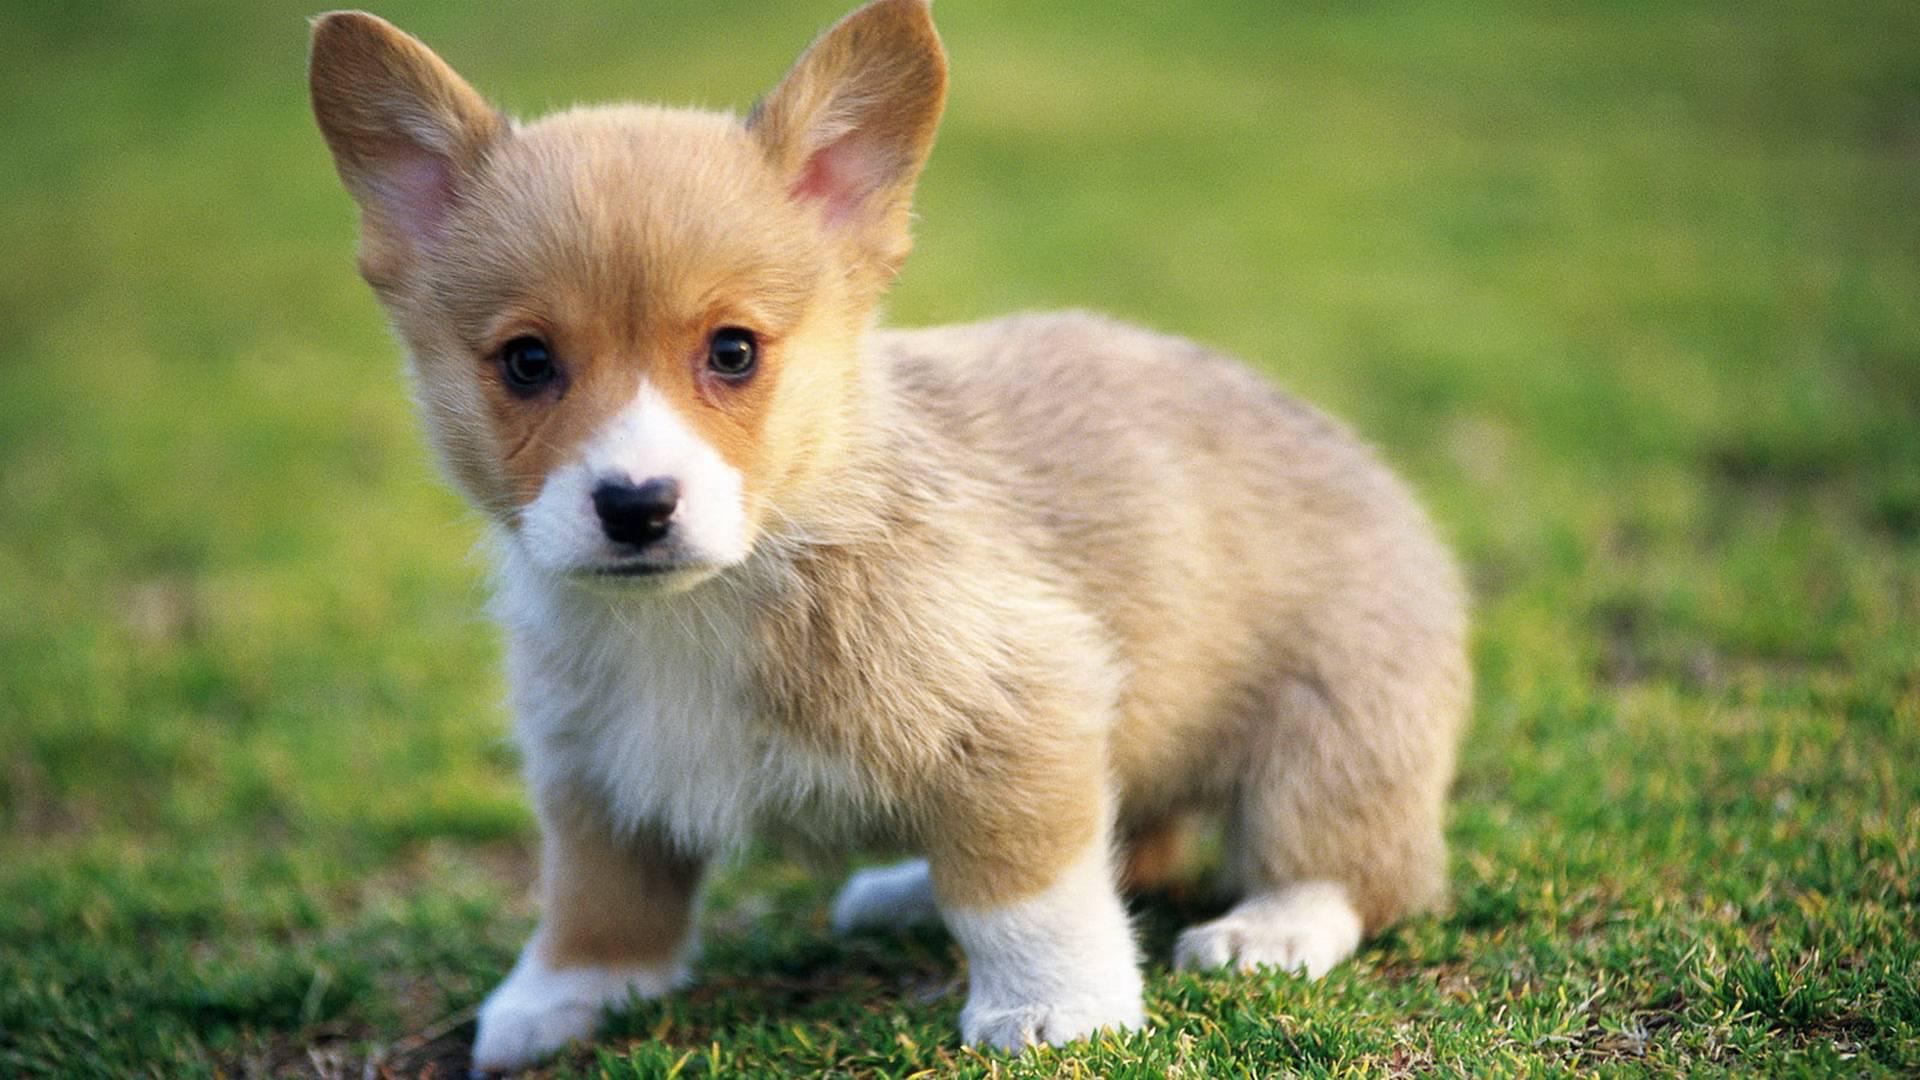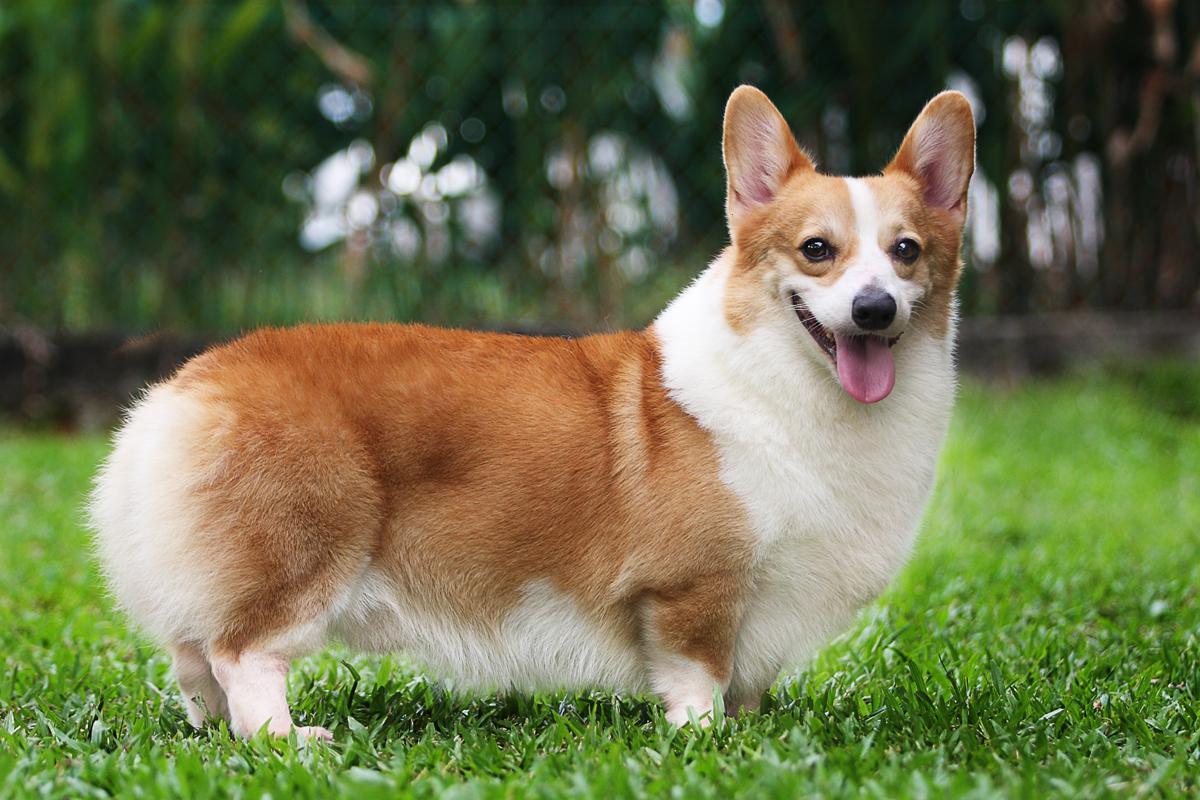The first image is the image on the left, the second image is the image on the right. For the images shown, is this caption "An image shows a corgi standing in grass with leftward foot raised." true? Answer yes or no. No. The first image is the image on the left, the second image is the image on the right. Evaluate the accuracy of this statement regarding the images: "One of the dogs is lying in the grass.". Is it true? Answer yes or no. No. 